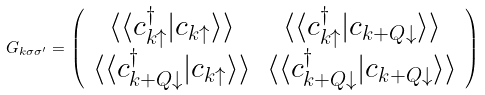Convert formula to latex. <formula><loc_0><loc_0><loc_500><loc_500>G _ { { k } \sigma \sigma ^ { \prime } } = \left ( \begin{array} { c c } \langle \langle c ^ { \dagger } _ { { k } \uparrow } | c _ { { k } \uparrow } \rangle \rangle & \langle \langle c ^ { \dagger } _ { { k } \uparrow } | c _ { { k + Q } \downarrow } \rangle \rangle \\ \langle \langle c ^ { \dagger } _ { { k + Q } \downarrow } | c _ { { k } \uparrow } \rangle \rangle & \langle \langle c ^ { \dagger } _ { { k + Q } \downarrow } | c _ { { k + Q } \downarrow } \rangle \rangle \end{array} \right )</formula> 